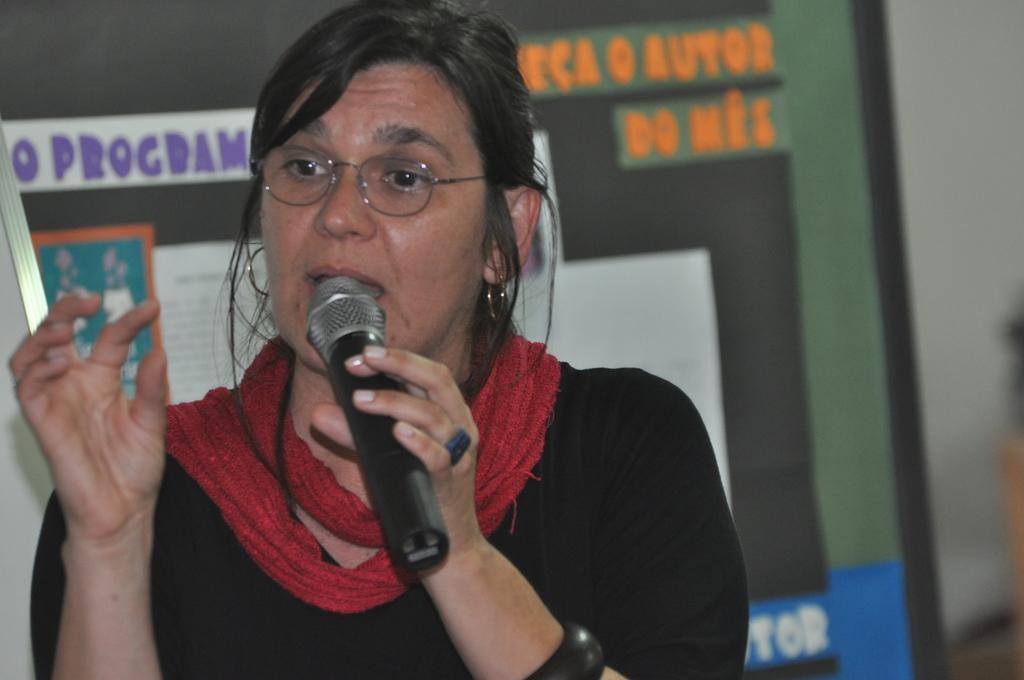Can you describe this image briefly? In this image I can see a woman standing and holding a mike in her hand is talking. I can see a board behind her with some posters and with some text. The background is blurred. 